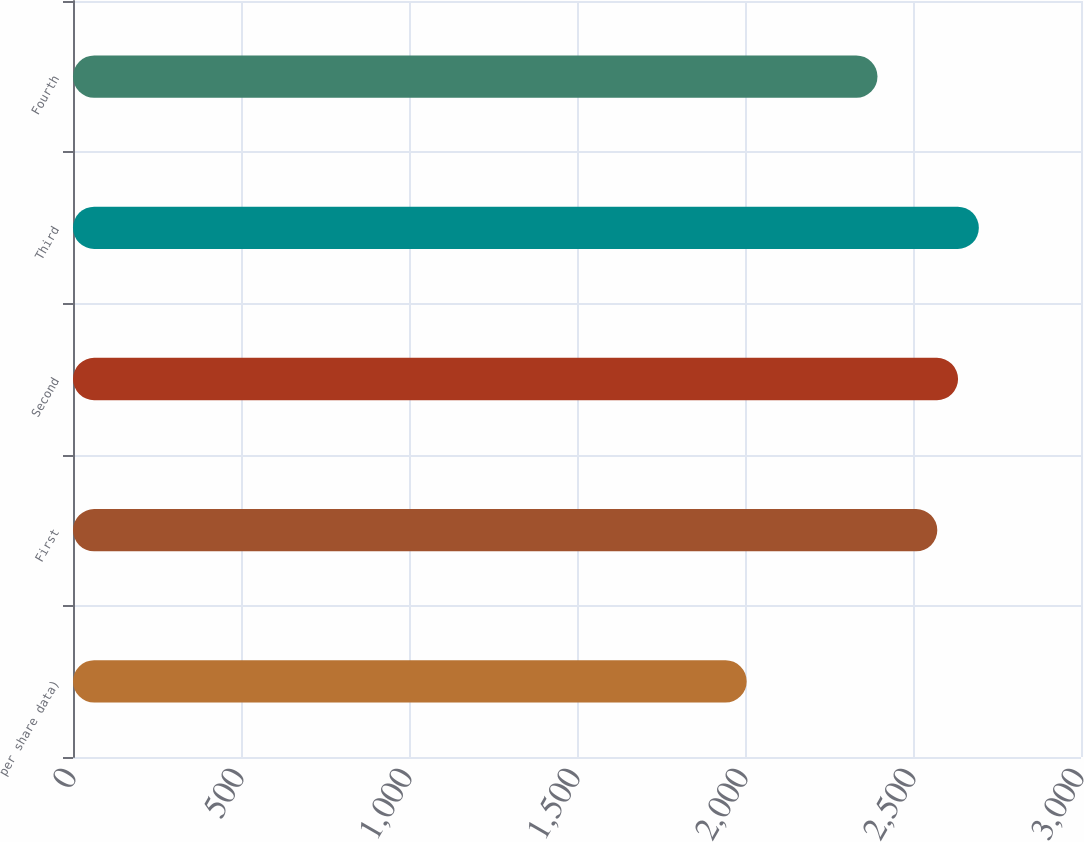Convert chart to OTSL. <chart><loc_0><loc_0><loc_500><loc_500><bar_chart><fcel>per share data)<fcel>First<fcel>Second<fcel>Third<fcel>Fourth<nl><fcel>2005<fcel>2572.3<fcel>2634.14<fcel>2695.98<fcel>2394.3<nl></chart> 